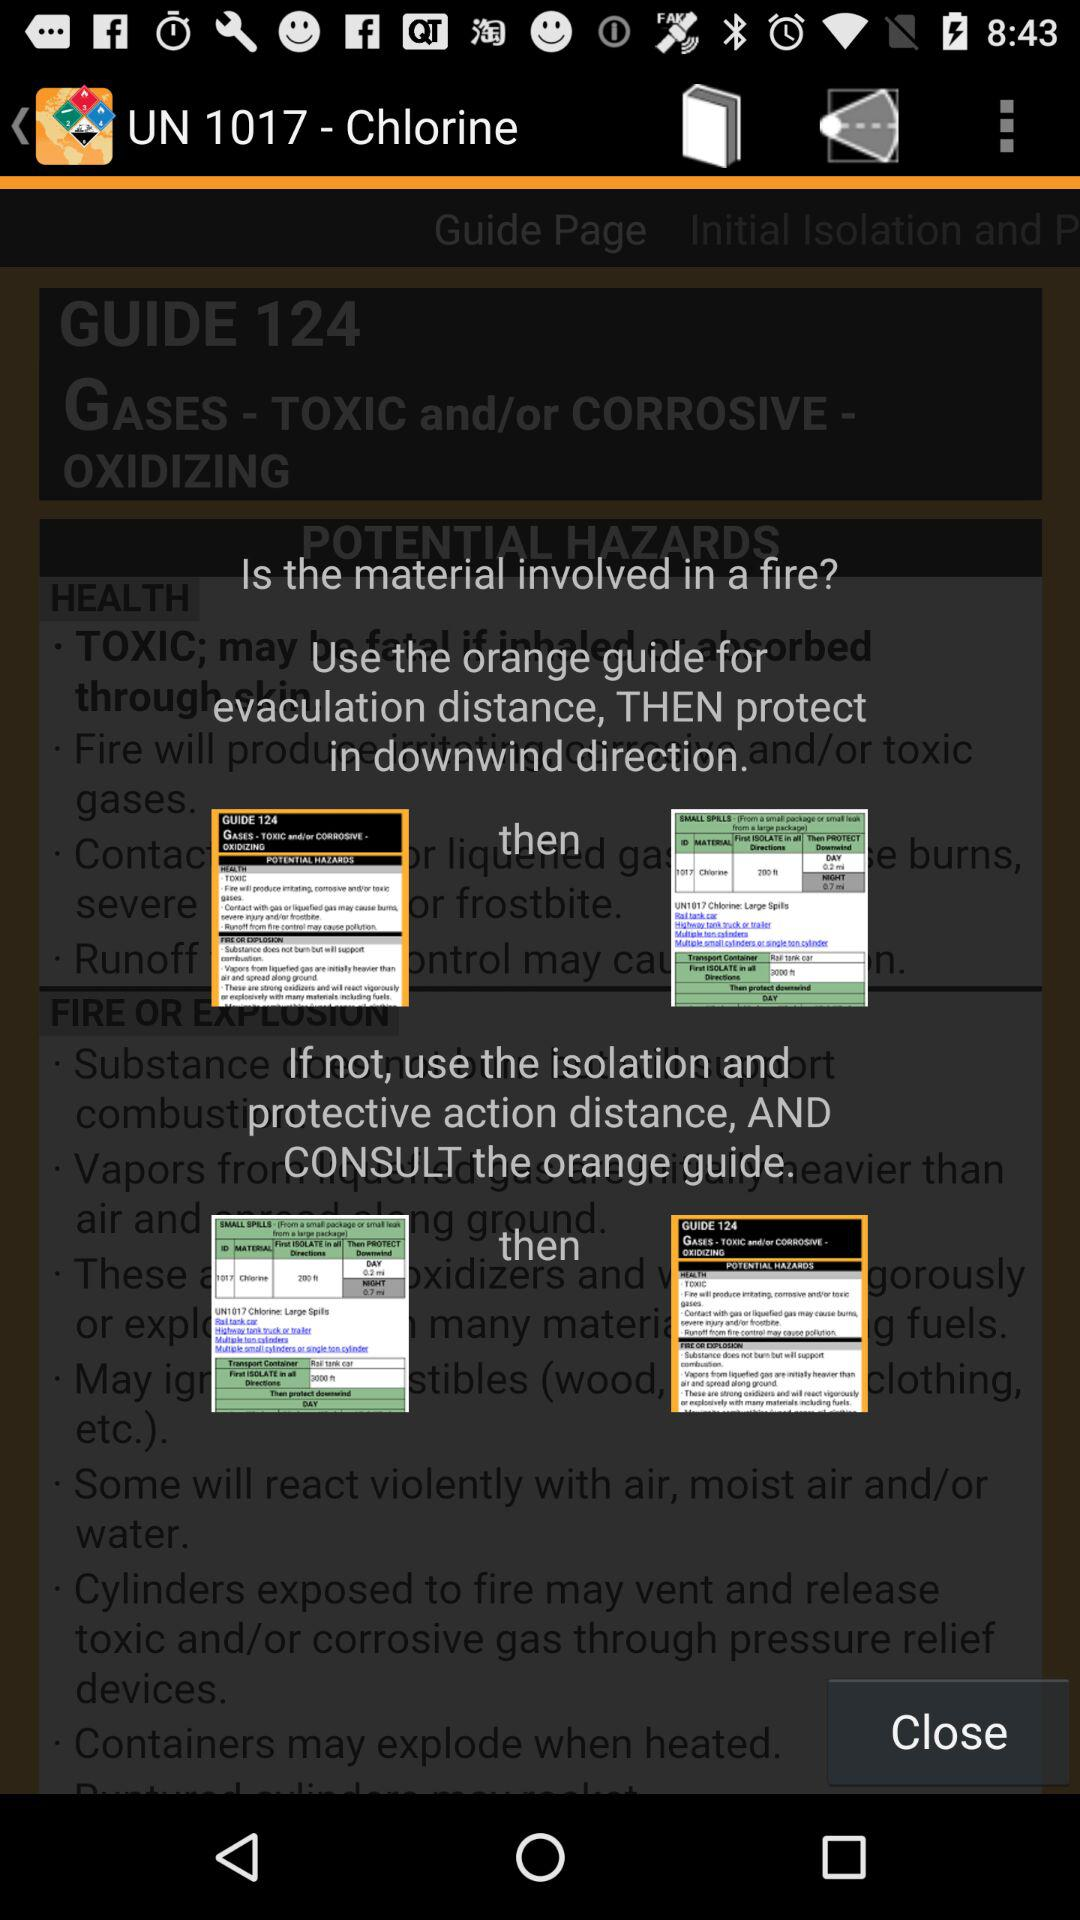What is the name of the application? The name of the application is "ERG 2016". 